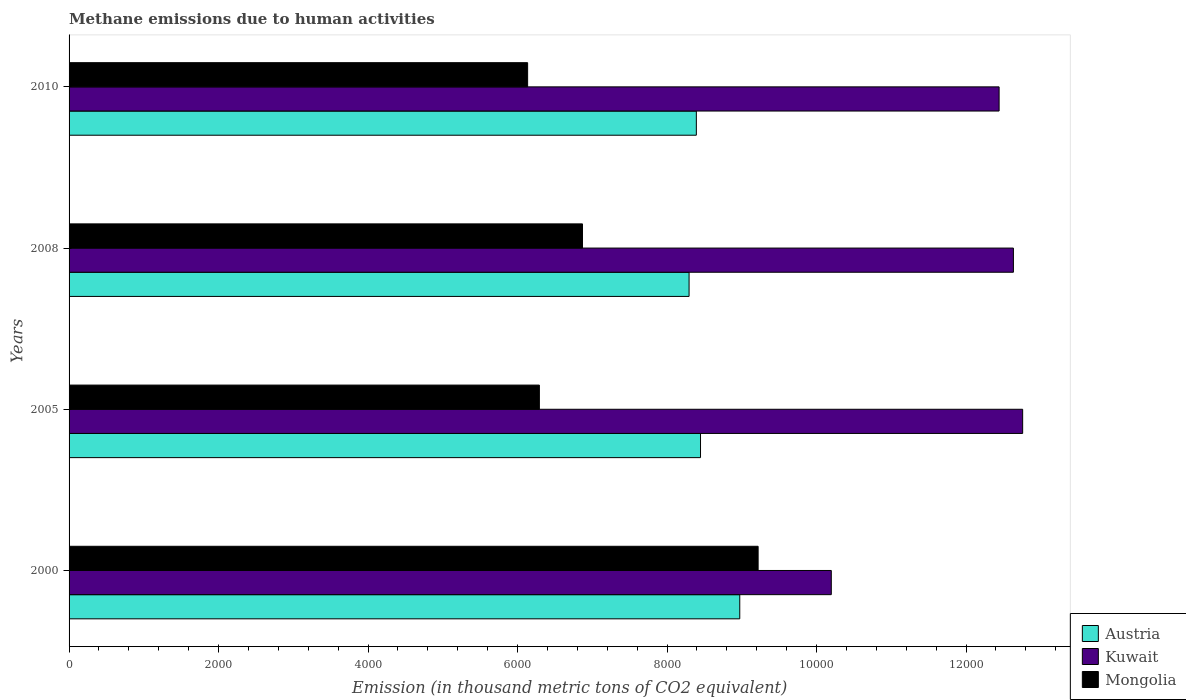How many groups of bars are there?
Ensure brevity in your answer.  4. Are the number of bars on each tick of the Y-axis equal?
Ensure brevity in your answer.  Yes. How many bars are there on the 1st tick from the top?
Offer a very short reply. 3. In how many cases, is the number of bars for a given year not equal to the number of legend labels?
Your response must be concise. 0. What is the amount of methane emitted in Kuwait in 2000?
Your answer should be very brief. 1.02e+04. Across all years, what is the maximum amount of methane emitted in Kuwait?
Keep it short and to the point. 1.28e+04. Across all years, what is the minimum amount of methane emitted in Kuwait?
Offer a terse response. 1.02e+04. In which year was the amount of methane emitted in Kuwait maximum?
Keep it short and to the point. 2005. In which year was the amount of methane emitted in Kuwait minimum?
Provide a succinct answer. 2000. What is the total amount of methane emitted in Austria in the graph?
Offer a very short reply. 3.41e+04. What is the difference between the amount of methane emitted in Kuwait in 2000 and that in 2010?
Offer a terse response. -2244.9. What is the difference between the amount of methane emitted in Mongolia in 2000 and the amount of methane emitted in Kuwait in 2008?
Provide a succinct answer. -3415.2. What is the average amount of methane emitted in Mongolia per year?
Offer a very short reply. 7128.02. In the year 2008, what is the difference between the amount of methane emitted in Austria and amount of methane emitted in Kuwait?
Provide a succinct answer. -4338.9. What is the ratio of the amount of methane emitted in Austria in 2000 to that in 2008?
Your response must be concise. 1.08. Is the amount of methane emitted in Mongolia in 2005 less than that in 2010?
Provide a succinct answer. No. Is the difference between the amount of methane emitted in Austria in 2005 and 2008 greater than the difference between the amount of methane emitted in Kuwait in 2005 and 2008?
Give a very brief answer. Yes. What is the difference between the highest and the second highest amount of methane emitted in Mongolia?
Make the answer very short. 2349.6. What is the difference between the highest and the lowest amount of methane emitted in Kuwait?
Make the answer very short. 2560. In how many years, is the amount of methane emitted in Austria greater than the average amount of methane emitted in Austria taken over all years?
Ensure brevity in your answer.  1. What does the 1st bar from the top in 2005 represents?
Make the answer very short. Mongolia. Are all the bars in the graph horizontal?
Keep it short and to the point. Yes. How many years are there in the graph?
Provide a succinct answer. 4. What is the difference between two consecutive major ticks on the X-axis?
Your answer should be compact. 2000. Are the values on the major ticks of X-axis written in scientific E-notation?
Give a very brief answer. No. Does the graph contain grids?
Your answer should be compact. No. How many legend labels are there?
Offer a very short reply. 3. What is the title of the graph?
Keep it short and to the point. Methane emissions due to human activities. Does "Montenegro" appear as one of the legend labels in the graph?
Offer a terse response. No. What is the label or title of the X-axis?
Keep it short and to the point. Emission (in thousand metric tons of CO2 equivalent). What is the label or title of the Y-axis?
Ensure brevity in your answer.  Years. What is the Emission (in thousand metric tons of CO2 equivalent) in Austria in 2000?
Offer a terse response. 8972.4. What is the Emission (in thousand metric tons of CO2 equivalent) in Kuwait in 2000?
Give a very brief answer. 1.02e+04. What is the Emission (in thousand metric tons of CO2 equivalent) in Mongolia in 2000?
Keep it short and to the point. 9217.9. What is the Emission (in thousand metric tons of CO2 equivalent) in Austria in 2005?
Your answer should be very brief. 8447.3. What is the Emission (in thousand metric tons of CO2 equivalent) of Kuwait in 2005?
Make the answer very short. 1.28e+04. What is the Emission (in thousand metric tons of CO2 equivalent) in Mongolia in 2005?
Your answer should be compact. 6291.5. What is the Emission (in thousand metric tons of CO2 equivalent) of Austria in 2008?
Keep it short and to the point. 8294.2. What is the Emission (in thousand metric tons of CO2 equivalent) in Kuwait in 2008?
Make the answer very short. 1.26e+04. What is the Emission (in thousand metric tons of CO2 equivalent) in Mongolia in 2008?
Provide a short and direct response. 6868.3. What is the Emission (in thousand metric tons of CO2 equivalent) in Austria in 2010?
Keep it short and to the point. 8391.4. What is the Emission (in thousand metric tons of CO2 equivalent) of Kuwait in 2010?
Provide a short and direct response. 1.24e+04. What is the Emission (in thousand metric tons of CO2 equivalent) of Mongolia in 2010?
Give a very brief answer. 6134.4. Across all years, what is the maximum Emission (in thousand metric tons of CO2 equivalent) in Austria?
Make the answer very short. 8972.4. Across all years, what is the maximum Emission (in thousand metric tons of CO2 equivalent) in Kuwait?
Provide a short and direct response. 1.28e+04. Across all years, what is the maximum Emission (in thousand metric tons of CO2 equivalent) in Mongolia?
Offer a terse response. 9217.9. Across all years, what is the minimum Emission (in thousand metric tons of CO2 equivalent) in Austria?
Your answer should be very brief. 8294.2. Across all years, what is the minimum Emission (in thousand metric tons of CO2 equivalent) in Kuwait?
Your answer should be very brief. 1.02e+04. Across all years, what is the minimum Emission (in thousand metric tons of CO2 equivalent) in Mongolia?
Offer a terse response. 6134.4. What is the total Emission (in thousand metric tons of CO2 equivalent) of Austria in the graph?
Make the answer very short. 3.41e+04. What is the total Emission (in thousand metric tons of CO2 equivalent) of Kuwait in the graph?
Keep it short and to the point. 4.80e+04. What is the total Emission (in thousand metric tons of CO2 equivalent) of Mongolia in the graph?
Ensure brevity in your answer.  2.85e+04. What is the difference between the Emission (in thousand metric tons of CO2 equivalent) in Austria in 2000 and that in 2005?
Your answer should be compact. 525.1. What is the difference between the Emission (in thousand metric tons of CO2 equivalent) in Kuwait in 2000 and that in 2005?
Make the answer very short. -2560. What is the difference between the Emission (in thousand metric tons of CO2 equivalent) of Mongolia in 2000 and that in 2005?
Your answer should be compact. 2926.4. What is the difference between the Emission (in thousand metric tons of CO2 equivalent) of Austria in 2000 and that in 2008?
Your response must be concise. 678.2. What is the difference between the Emission (in thousand metric tons of CO2 equivalent) of Kuwait in 2000 and that in 2008?
Offer a terse response. -2436.3. What is the difference between the Emission (in thousand metric tons of CO2 equivalent) in Mongolia in 2000 and that in 2008?
Offer a terse response. 2349.6. What is the difference between the Emission (in thousand metric tons of CO2 equivalent) of Austria in 2000 and that in 2010?
Your answer should be compact. 581. What is the difference between the Emission (in thousand metric tons of CO2 equivalent) of Kuwait in 2000 and that in 2010?
Provide a short and direct response. -2244.9. What is the difference between the Emission (in thousand metric tons of CO2 equivalent) of Mongolia in 2000 and that in 2010?
Provide a short and direct response. 3083.5. What is the difference between the Emission (in thousand metric tons of CO2 equivalent) of Austria in 2005 and that in 2008?
Offer a terse response. 153.1. What is the difference between the Emission (in thousand metric tons of CO2 equivalent) of Kuwait in 2005 and that in 2008?
Offer a very short reply. 123.7. What is the difference between the Emission (in thousand metric tons of CO2 equivalent) in Mongolia in 2005 and that in 2008?
Keep it short and to the point. -576.8. What is the difference between the Emission (in thousand metric tons of CO2 equivalent) in Austria in 2005 and that in 2010?
Provide a succinct answer. 55.9. What is the difference between the Emission (in thousand metric tons of CO2 equivalent) in Kuwait in 2005 and that in 2010?
Give a very brief answer. 315.1. What is the difference between the Emission (in thousand metric tons of CO2 equivalent) in Mongolia in 2005 and that in 2010?
Give a very brief answer. 157.1. What is the difference between the Emission (in thousand metric tons of CO2 equivalent) of Austria in 2008 and that in 2010?
Keep it short and to the point. -97.2. What is the difference between the Emission (in thousand metric tons of CO2 equivalent) of Kuwait in 2008 and that in 2010?
Give a very brief answer. 191.4. What is the difference between the Emission (in thousand metric tons of CO2 equivalent) in Mongolia in 2008 and that in 2010?
Your answer should be compact. 733.9. What is the difference between the Emission (in thousand metric tons of CO2 equivalent) in Austria in 2000 and the Emission (in thousand metric tons of CO2 equivalent) in Kuwait in 2005?
Make the answer very short. -3784.4. What is the difference between the Emission (in thousand metric tons of CO2 equivalent) in Austria in 2000 and the Emission (in thousand metric tons of CO2 equivalent) in Mongolia in 2005?
Give a very brief answer. 2680.9. What is the difference between the Emission (in thousand metric tons of CO2 equivalent) of Kuwait in 2000 and the Emission (in thousand metric tons of CO2 equivalent) of Mongolia in 2005?
Offer a very short reply. 3905.3. What is the difference between the Emission (in thousand metric tons of CO2 equivalent) of Austria in 2000 and the Emission (in thousand metric tons of CO2 equivalent) of Kuwait in 2008?
Keep it short and to the point. -3660.7. What is the difference between the Emission (in thousand metric tons of CO2 equivalent) in Austria in 2000 and the Emission (in thousand metric tons of CO2 equivalent) in Mongolia in 2008?
Your response must be concise. 2104.1. What is the difference between the Emission (in thousand metric tons of CO2 equivalent) in Kuwait in 2000 and the Emission (in thousand metric tons of CO2 equivalent) in Mongolia in 2008?
Provide a short and direct response. 3328.5. What is the difference between the Emission (in thousand metric tons of CO2 equivalent) in Austria in 2000 and the Emission (in thousand metric tons of CO2 equivalent) in Kuwait in 2010?
Give a very brief answer. -3469.3. What is the difference between the Emission (in thousand metric tons of CO2 equivalent) in Austria in 2000 and the Emission (in thousand metric tons of CO2 equivalent) in Mongolia in 2010?
Give a very brief answer. 2838. What is the difference between the Emission (in thousand metric tons of CO2 equivalent) of Kuwait in 2000 and the Emission (in thousand metric tons of CO2 equivalent) of Mongolia in 2010?
Your answer should be compact. 4062.4. What is the difference between the Emission (in thousand metric tons of CO2 equivalent) of Austria in 2005 and the Emission (in thousand metric tons of CO2 equivalent) of Kuwait in 2008?
Ensure brevity in your answer.  -4185.8. What is the difference between the Emission (in thousand metric tons of CO2 equivalent) of Austria in 2005 and the Emission (in thousand metric tons of CO2 equivalent) of Mongolia in 2008?
Ensure brevity in your answer.  1579. What is the difference between the Emission (in thousand metric tons of CO2 equivalent) of Kuwait in 2005 and the Emission (in thousand metric tons of CO2 equivalent) of Mongolia in 2008?
Your response must be concise. 5888.5. What is the difference between the Emission (in thousand metric tons of CO2 equivalent) in Austria in 2005 and the Emission (in thousand metric tons of CO2 equivalent) in Kuwait in 2010?
Offer a terse response. -3994.4. What is the difference between the Emission (in thousand metric tons of CO2 equivalent) in Austria in 2005 and the Emission (in thousand metric tons of CO2 equivalent) in Mongolia in 2010?
Offer a very short reply. 2312.9. What is the difference between the Emission (in thousand metric tons of CO2 equivalent) in Kuwait in 2005 and the Emission (in thousand metric tons of CO2 equivalent) in Mongolia in 2010?
Provide a short and direct response. 6622.4. What is the difference between the Emission (in thousand metric tons of CO2 equivalent) of Austria in 2008 and the Emission (in thousand metric tons of CO2 equivalent) of Kuwait in 2010?
Ensure brevity in your answer.  -4147.5. What is the difference between the Emission (in thousand metric tons of CO2 equivalent) in Austria in 2008 and the Emission (in thousand metric tons of CO2 equivalent) in Mongolia in 2010?
Your response must be concise. 2159.8. What is the difference between the Emission (in thousand metric tons of CO2 equivalent) of Kuwait in 2008 and the Emission (in thousand metric tons of CO2 equivalent) of Mongolia in 2010?
Provide a short and direct response. 6498.7. What is the average Emission (in thousand metric tons of CO2 equivalent) in Austria per year?
Keep it short and to the point. 8526.33. What is the average Emission (in thousand metric tons of CO2 equivalent) of Kuwait per year?
Give a very brief answer. 1.20e+04. What is the average Emission (in thousand metric tons of CO2 equivalent) of Mongolia per year?
Provide a short and direct response. 7128.02. In the year 2000, what is the difference between the Emission (in thousand metric tons of CO2 equivalent) in Austria and Emission (in thousand metric tons of CO2 equivalent) in Kuwait?
Your answer should be very brief. -1224.4. In the year 2000, what is the difference between the Emission (in thousand metric tons of CO2 equivalent) of Austria and Emission (in thousand metric tons of CO2 equivalent) of Mongolia?
Provide a succinct answer. -245.5. In the year 2000, what is the difference between the Emission (in thousand metric tons of CO2 equivalent) in Kuwait and Emission (in thousand metric tons of CO2 equivalent) in Mongolia?
Keep it short and to the point. 978.9. In the year 2005, what is the difference between the Emission (in thousand metric tons of CO2 equivalent) in Austria and Emission (in thousand metric tons of CO2 equivalent) in Kuwait?
Offer a very short reply. -4309.5. In the year 2005, what is the difference between the Emission (in thousand metric tons of CO2 equivalent) of Austria and Emission (in thousand metric tons of CO2 equivalent) of Mongolia?
Keep it short and to the point. 2155.8. In the year 2005, what is the difference between the Emission (in thousand metric tons of CO2 equivalent) in Kuwait and Emission (in thousand metric tons of CO2 equivalent) in Mongolia?
Provide a short and direct response. 6465.3. In the year 2008, what is the difference between the Emission (in thousand metric tons of CO2 equivalent) in Austria and Emission (in thousand metric tons of CO2 equivalent) in Kuwait?
Offer a very short reply. -4338.9. In the year 2008, what is the difference between the Emission (in thousand metric tons of CO2 equivalent) in Austria and Emission (in thousand metric tons of CO2 equivalent) in Mongolia?
Provide a succinct answer. 1425.9. In the year 2008, what is the difference between the Emission (in thousand metric tons of CO2 equivalent) of Kuwait and Emission (in thousand metric tons of CO2 equivalent) of Mongolia?
Your answer should be compact. 5764.8. In the year 2010, what is the difference between the Emission (in thousand metric tons of CO2 equivalent) of Austria and Emission (in thousand metric tons of CO2 equivalent) of Kuwait?
Your response must be concise. -4050.3. In the year 2010, what is the difference between the Emission (in thousand metric tons of CO2 equivalent) in Austria and Emission (in thousand metric tons of CO2 equivalent) in Mongolia?
Make the answer very short. 2257. In the year 2010, what is the difference between the Emission (in thousand metric tons of CO2 equivalent) in Kuwait and Emission (in thousand metric tons of CO2 equivalent) in Mongolia?
Offer a terse response. 6307.3. What is the ratio of the Emission (in thousand metric tons of CO2 equivalent) in Austria in 2000 to that in 2005?
Keep it short and to the point. 1.06. What is the ratio of the Emission (in thousand metric tons of CO2 equivalent) in Kuwait in 2000 to that in 2005?
Your answer should be compact. 0.8. What is the ratio of the Emission (in thousand metric tons of CO2 equivalent) of Mongolia in 2000 to that in 2005?
Your answer should be compact. 1.47. What is the ratio of the Emission (in thousand metric tons of CO2 equivalent) of Austria in 2000 to that in 2008?
Provide a succinct answer. 1.08. What is the ratio of the Emission (in thousand metric tons of CO2 equivalent) of Kuwait in 2000 to that in 2008?
Make the answer very short. 0.81. What is the ratio of the Emission (in thousand metric tons of CO2 equivalent) in Mongolia in 2000 to that in 2008?
Give a very brief answer. 1.34. What is the ratio of the Emission (in thousand metric tons of CO2 equivalent) of Austria in 2000 to that in 2010?
Keep it short and to the point. 1.07. What is the ratio of the Emission (in thousand metric tons of CO2 equivalent) in Kuwait in 2000 to that in 2010?
Provide a succinct answer. 0.82. What is the ratio of the Emission (in thousand metric tons of CO2 equivalent) of Mongolia in 2000 to that in 2010?
Your answer should be very brief. 1.5. What is the ratio of the Emission (in thousand metric tons of CO2 equivalent) in Austria in 2005 to that in 2008?
Make the answer very short. 1.02. What is the ratio of the Emission (in thousand metric tons of CO2 equivalent) in Kuwait in 2005 to that in 2008?
Give a very brief answer. 1.01. What is the ratio of the Emission (in thousand metric tons of CO2 equivalent) in Mongolia in 2005 to that in 2008?
Offer a terse response. 0.92. What is the ratio of the Emission (in thousand metric tons of CO2 equivalent) of Austria in 2005 to that in 2010?
Ensure brevity in your answer.  1.01. What is the ratio of the Emission (in thousand metric tons of CO2 equivalent) of Kuwait in 2005 to that in 2010?
Give a very brief answer. 1.03. What is the ratio of the Emission (in thousand metric tons of CO2 equivalent) of Mongolia in 2005 to that in 2010?
Your response must be concise. 1.03. What is the ratio of the Emission (in thousand metric tons of CO2 equivalent) of Austria in 2008 to that in 2010?
Offer a terse response. 0.99. What is the ratio of the Emission (in thousand metric tons of CO2 equivalent) of Kuwait in 2008 to that in 2010?
Your answer should be compact. 1.02. What is the ratio of the Emission (in thousand metric tons of CO2 equivalent) of Mongolia in 2008 to that in 2010?
Your response must be concise. 1.12. What is the difference between the highest and the second highest Emission (in thousand metric tons of CO2 equivalent) of Austria?
Keep it short and to the point. 525.1. What is the difference between the highest and the second highest Emission (in thousand metric tons of CO2 equivalent) of Kuwait?
Offer a very short reply. 123.7. What is the difference between the highest and the second highest Emission (in thousand metric tons of CO2 equivalent) of Mongolia?
Your answer should be very brief. 2349.6. What is the difference between the highest and the lowest Emission (in thousand metric tons of CO2 equivalent) in Austria?
Your response must be concise. 678.2. What is the difference between the highest and the lowest Emission (in thousand metric tons of CO2 equivalent) of Kuwait?
Your answer should be very brief. 2560. What is the difference between the highest and the lowest Emission (in thousand metric tons of CO2 equivalent) in Mongolia?
Ensure brevity in your answer.  3083.5. 